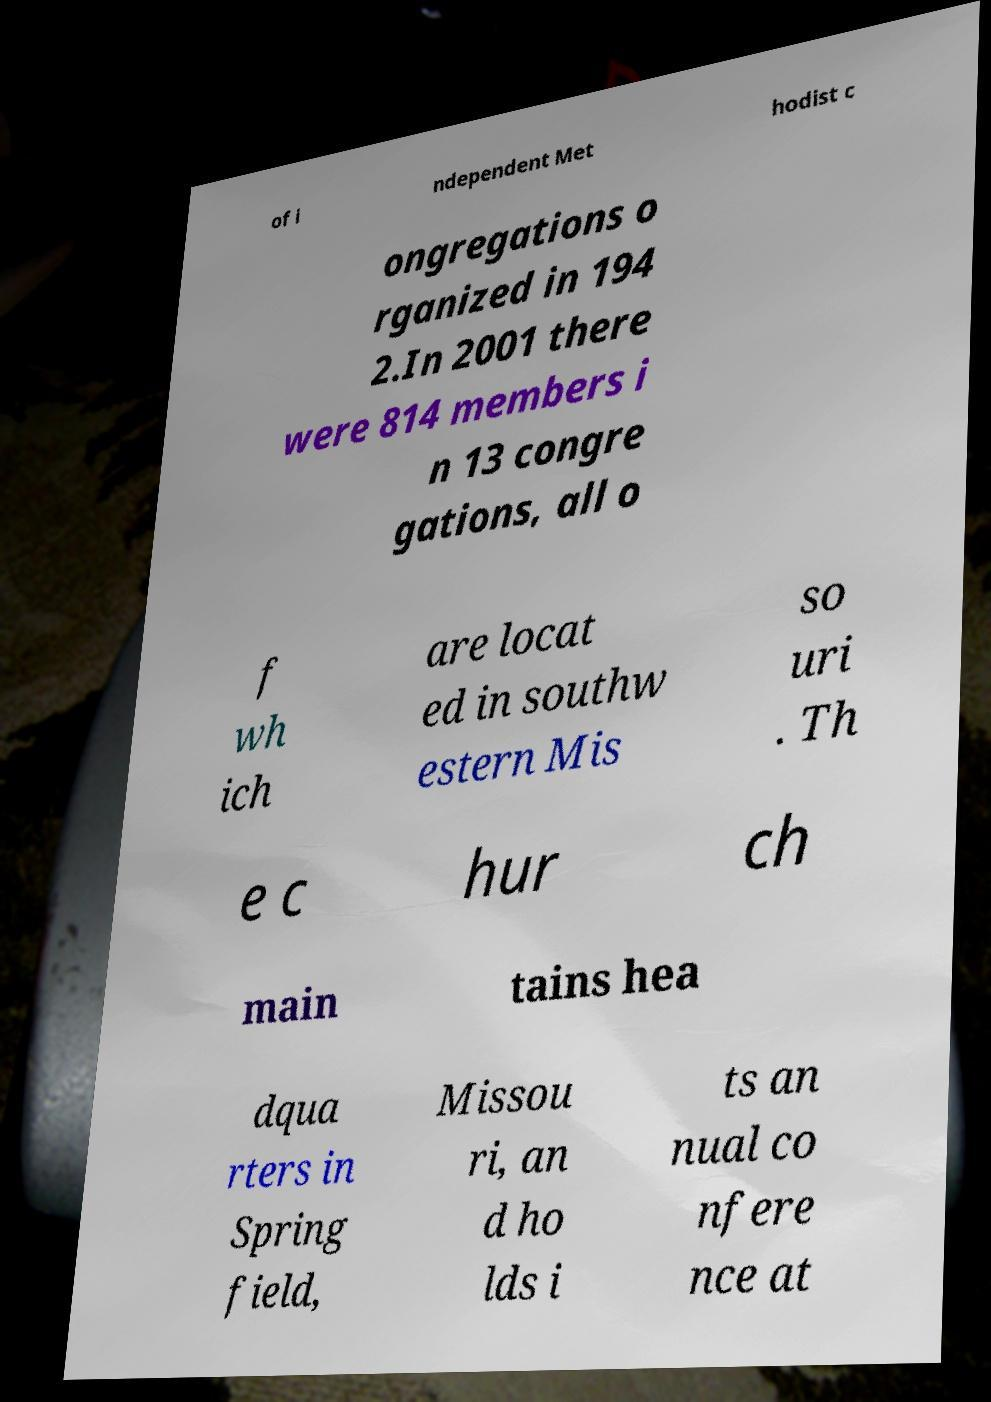For documentation purposes, I need the text within this image transcribed. Could you provide that? of i ndependent Met hodist c ongregations o rganized in 194 2.In 2001 there were 814 members i n 13 congre gations, all o f wh ich are locat ed in southw estern Mis so uri . Th e c hur ch main tains hea dqua rters in Spring field, Missou ri, an d ho lds i ts an nual co nfere nce at 